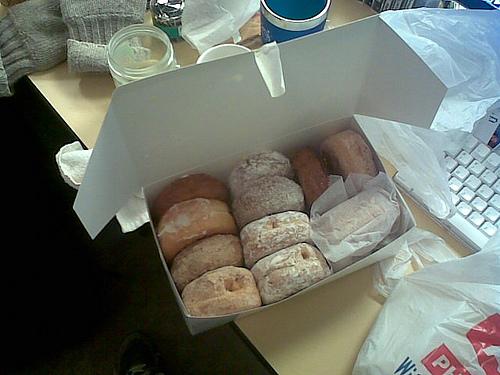Are the doughnuts chocolate?
Write a very short answer. No. Are these donuts homemade?
Quick response, please. No. How many donuts are there?
Quick response, please. 11. What are some of the shared characteristics of the variety of objects in the photo?
Short answer required. Donuts. 